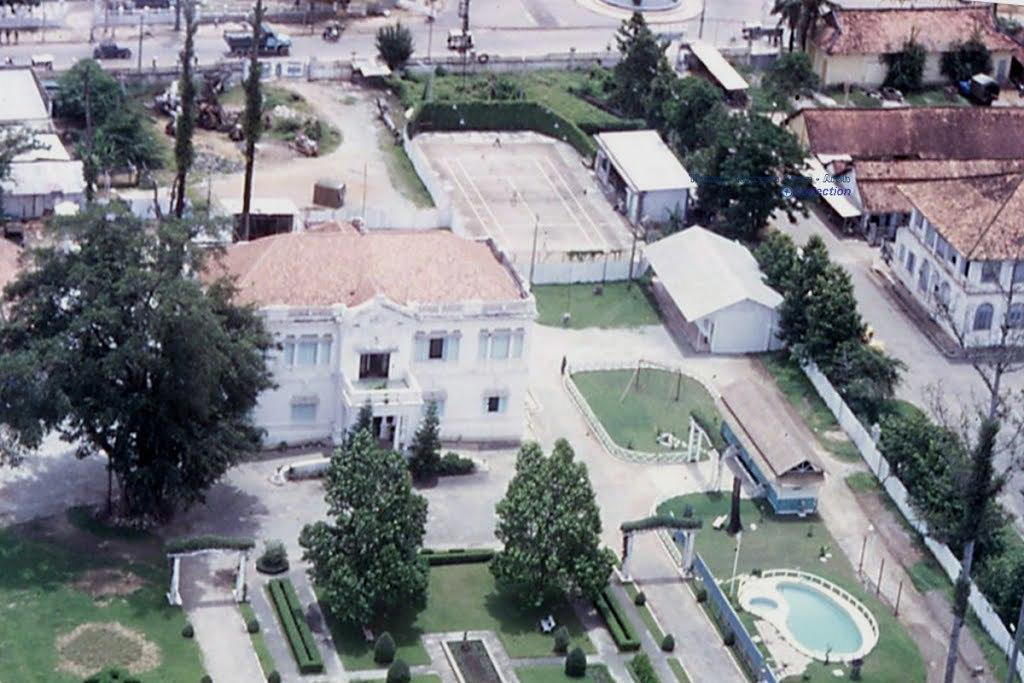What is the perspective of the image? The image shows a top view of buildings. What type of natural elements can be seen in the image? Trees, plants, and grass are visible in the image. What man-made structures are present in the image? Buildings, roads, and a pool are visible in the image. Are there any vehicles in the image? Yes, vehicles are present in the image. Can you see the crow's smile in the image? There is no crow or any indication of a smile in the image. 